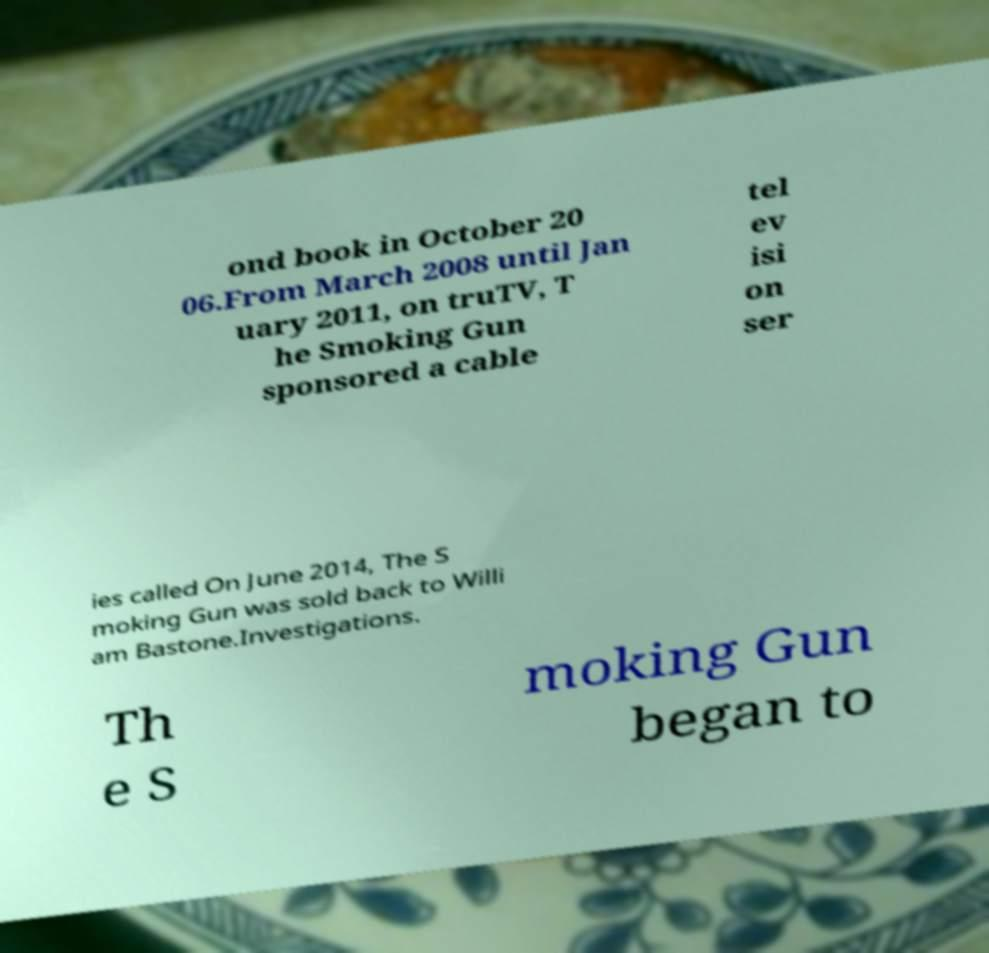I need the written content from this picture converted into text. Can you do that? ond book in October 20 06.From March 2008 until Jan uary 2011, on truTV, T he Smoking Gun sponsored a cable tel ev isi on ser ies called On June 2014, The S moking Gun was sold back to Willi am Bastone.Investigations. Th e S moking Gun began to 